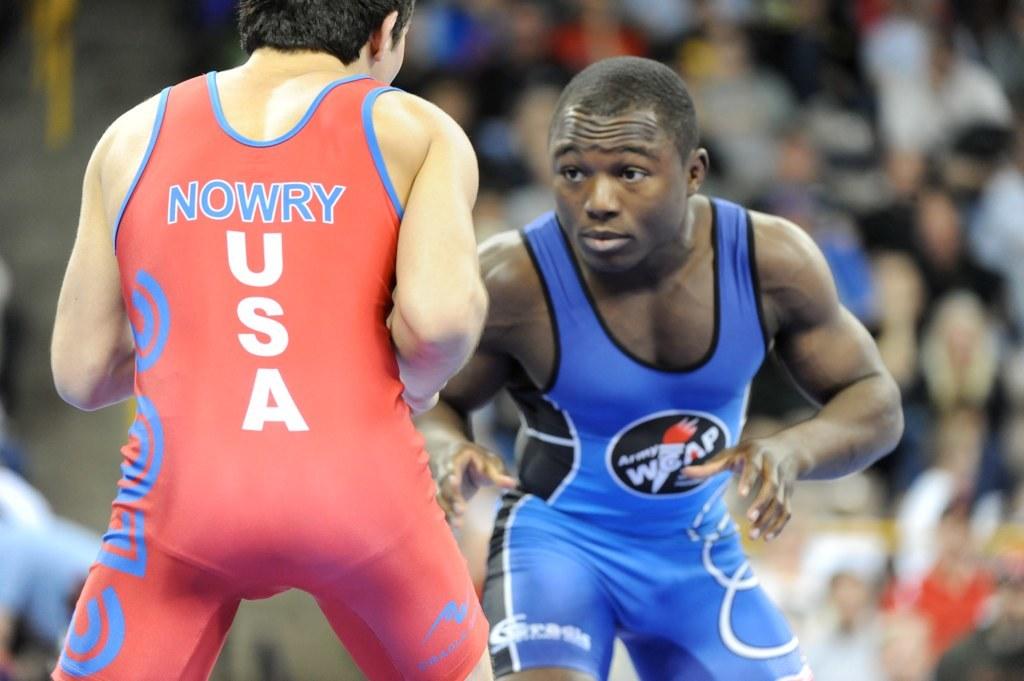What country does nowry represent?
Offer a very short reply. Usa. What is the acronym on the man in blue trunks?
Your answer should be compact. Wcap. 